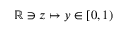<formula> <loc_0><loc_0><loc_500><loc_500>\mathbb { R } \ni z \mapsto y \in \left [ 0 , 1 \right )</formula> 